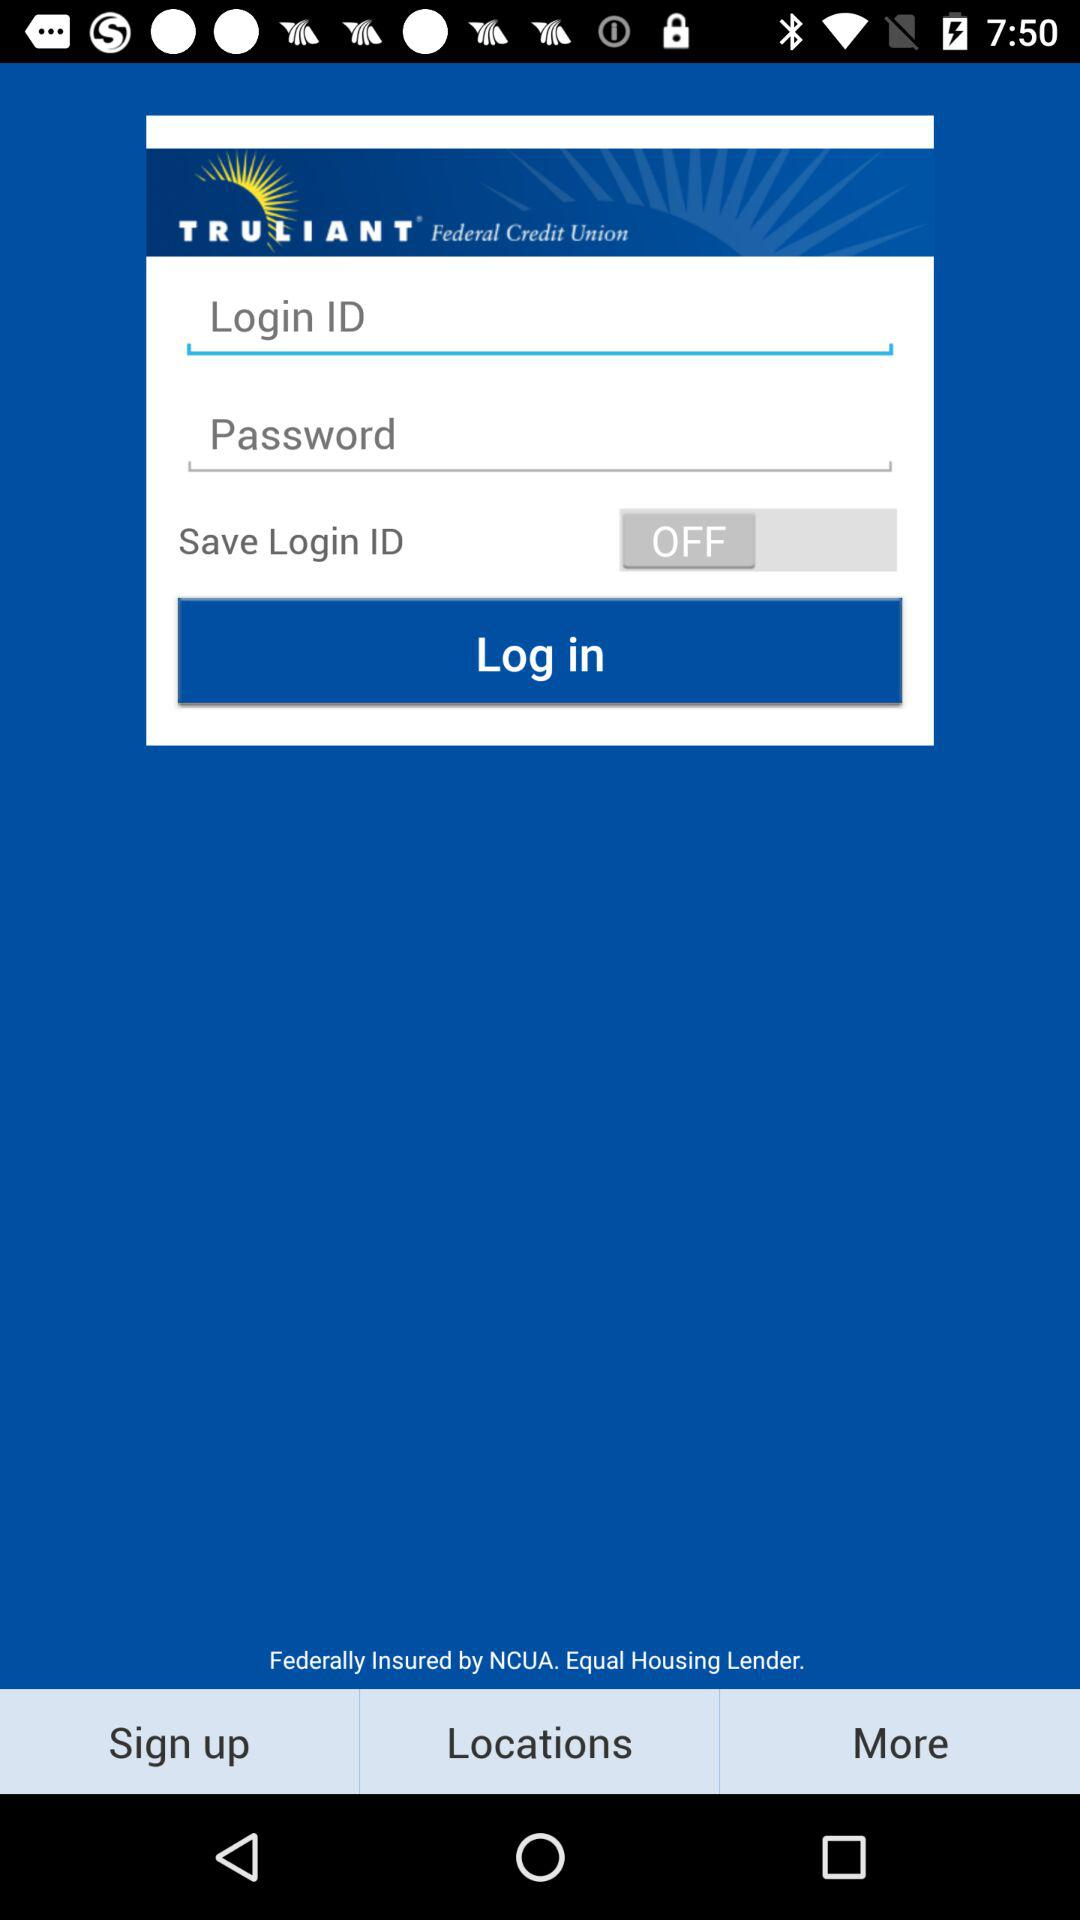What is the name of the application? The name of the application is "TRULIANT". 